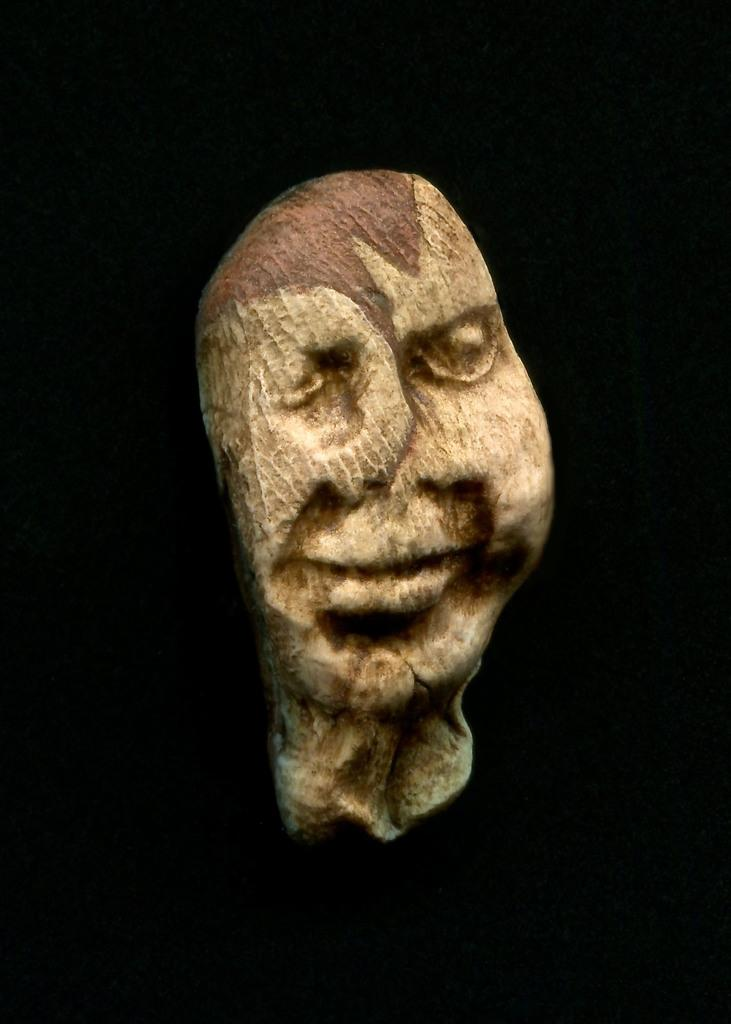What is the main subject of the image? There is an object in the image that resembles a human head. Can you describe the colors of the object? The object is cream and brown in color. What color is the background of the image? The background of the image is black. What type of fruit is being digested during the rainstorm in the image? There is no fruit, digestion, or rainstorm present in the image. 